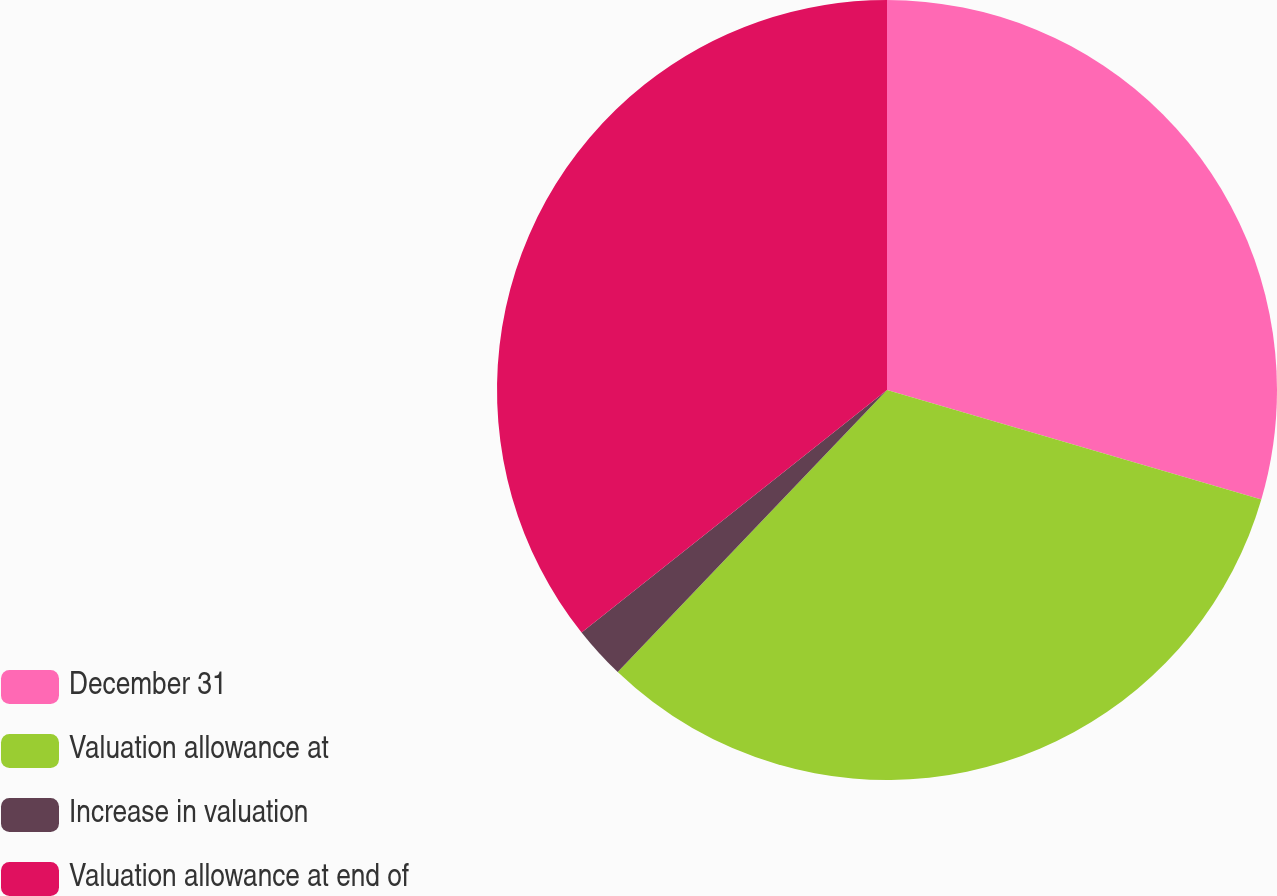<chart> <loc_0><loc_0><loc_500><loc_500><pie_chart><fcel>December 31<fcel>Valuation allowance at<fcel>Increase in valuation<fcel>Valuation allowance at end of<nl><fcel>29.53%<fcel>32.6%<fcel>2.19%<fcel>35.68%<nl></chart> 